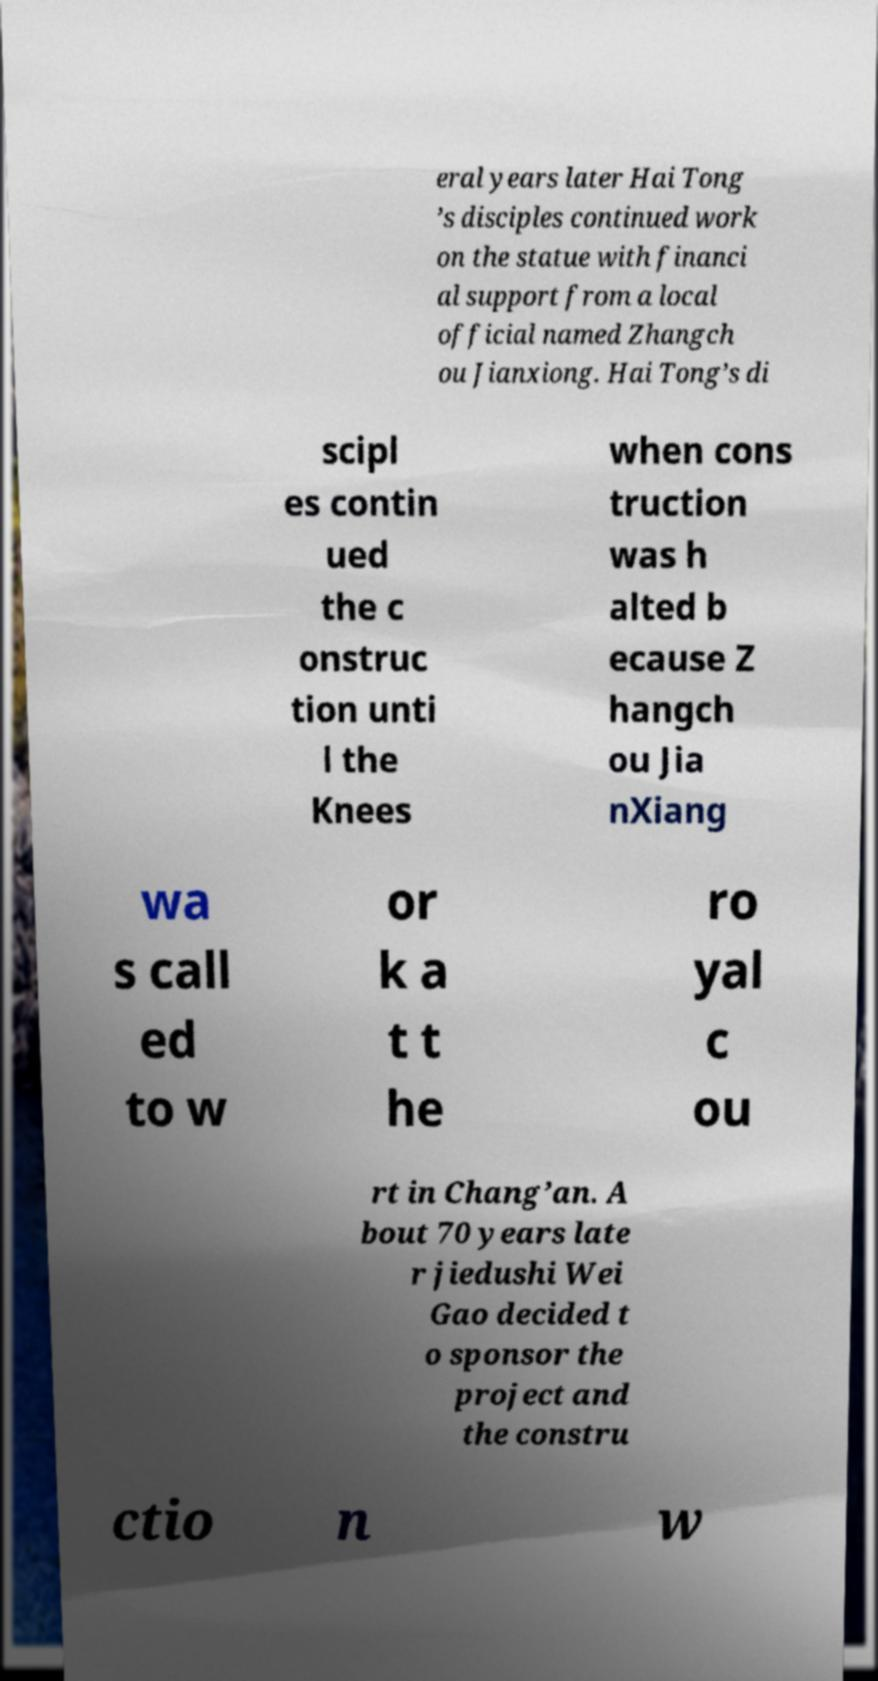I need the written content from this picture converted into text. Can you do that? eral years later Hai Tong ’s disciples continued work on the statue with financi al support from a local official named Zhangch ou Jianxiong. Hai Tong’s di scipl es contin ued the c onstruc tion unti l the Knees when cons truction was h alted b ecause Z hangch ou Jia nXiang wa s call ed to w or k a t t he ro yal c ou rt in Chang’an. A bout 70 years late r jiedushi Wei Gao decided t o sponsor the project and the constru ctio n w 